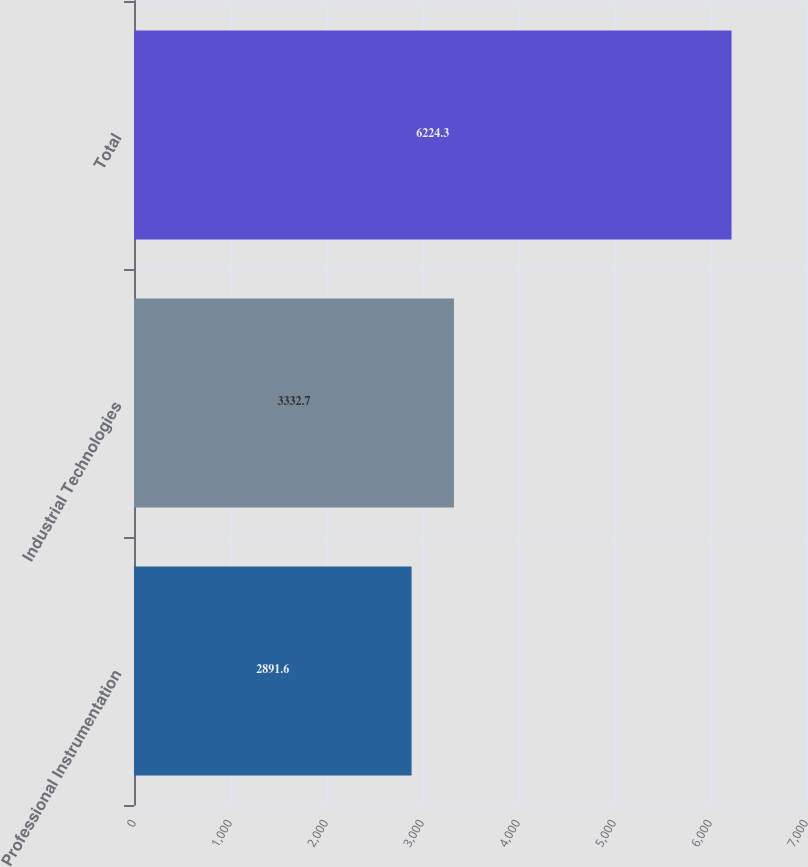Convert chart to OTSL. <chart><loc_0><loc_0><loc_500><loc_500><bar_chart><fcel>Professional Instrumentation<fcel>Industrial Technologies<fcel>Total<nl><fcel>2891.6<fcel>3332.7<fcel>6224.3<nl></chart> 